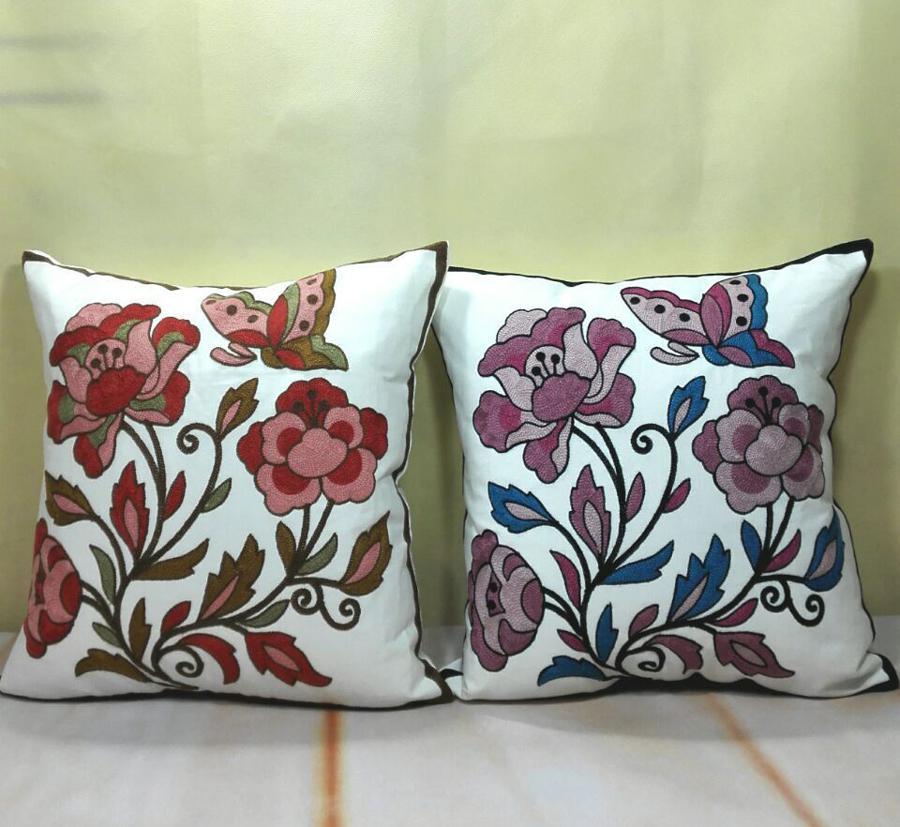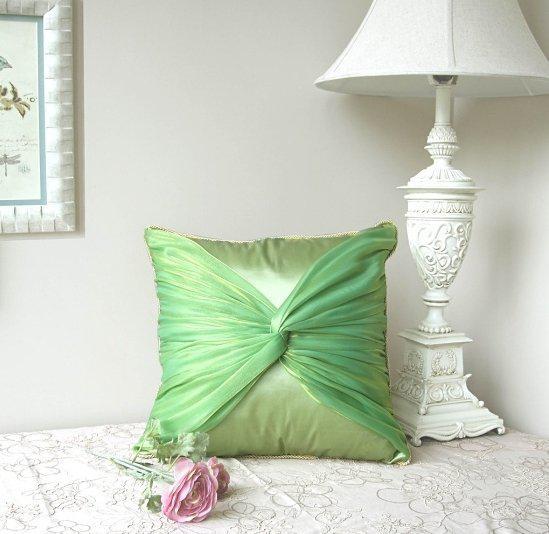The first image is the image on the left, the second image is the image on the right. For the images displayed, is the sentence "Each image shows at least three colorful throw pillows on a solid-colored sofa." factually correct? Answer yes or no. No. The first image is the image on the left, the second image is the image on the right. Evaluate the accuracy of this statement regarding the images: "Throw pillows are laid on a couch in each image.". Is it true? Answer yes or no. No. 